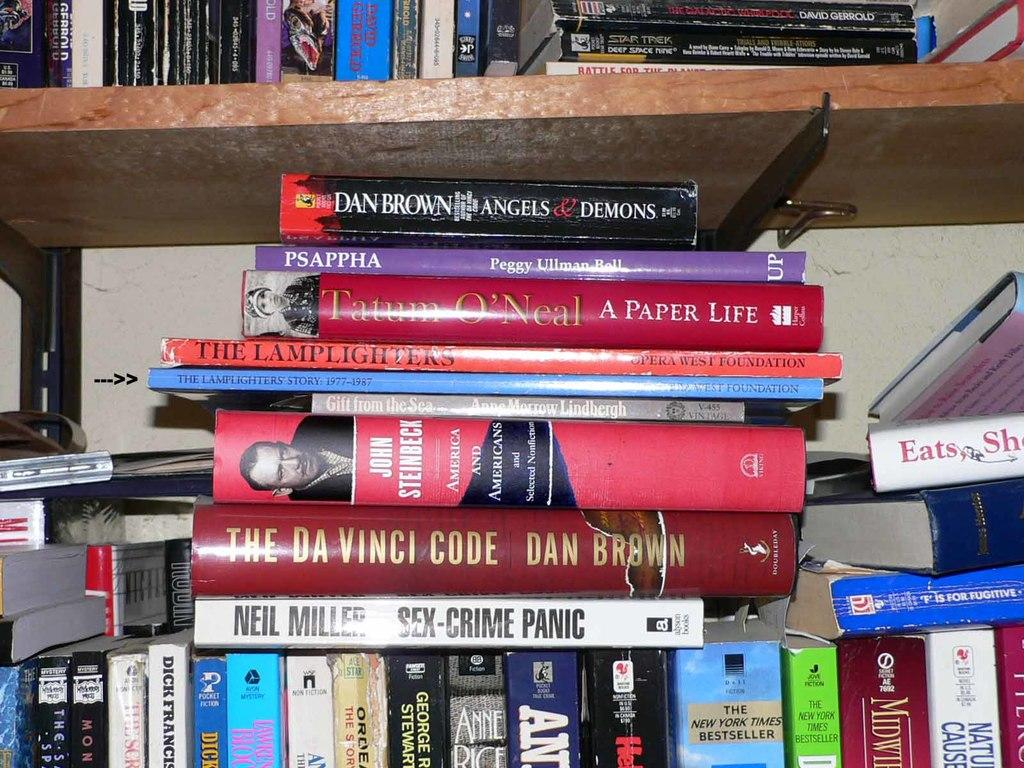<image>
Present a compact description of the photo's key features. Many books including, one titled, Angels & Demons, scattered among the shelves. 